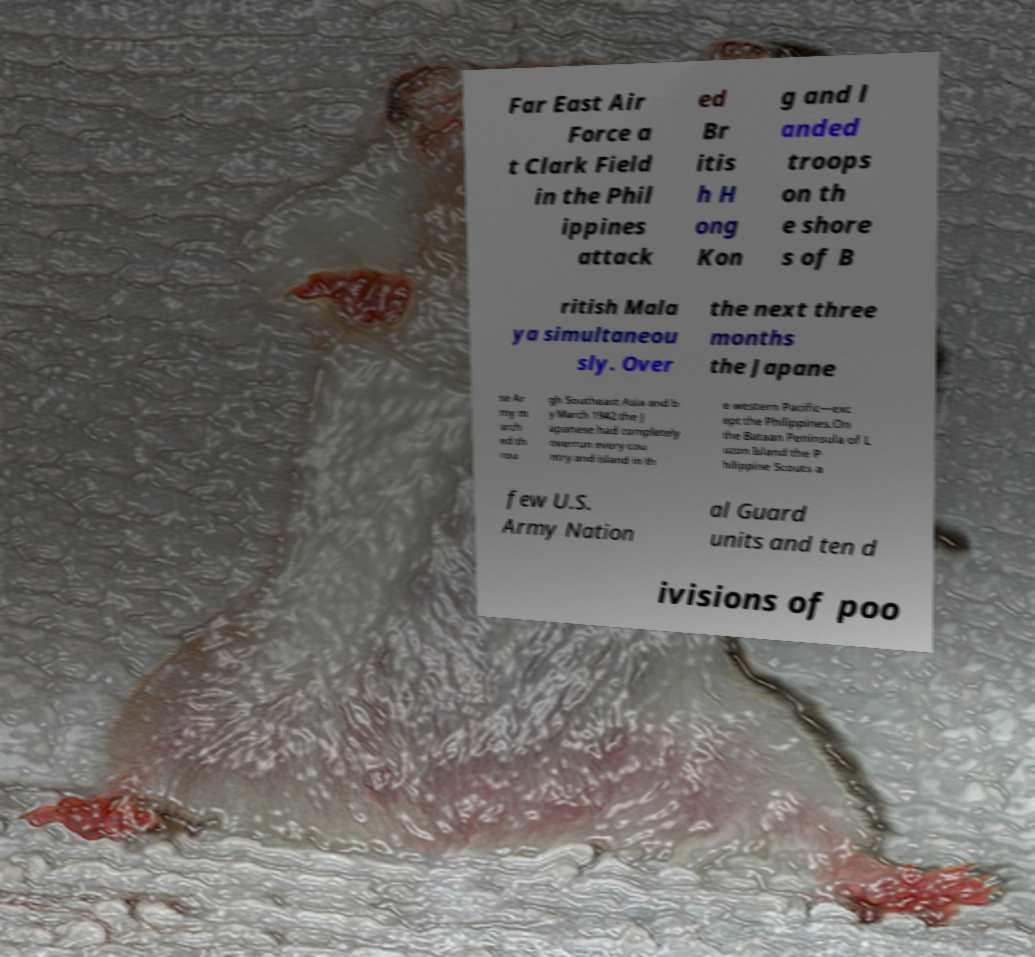Please identify and transcribe the text found in this image. Far East Air Force a t Clark Field in the Phil ippines attack ed Br itis h H ong Kon g and l anded troops on th e shore s of B ritish Mala ya simultaneou sly. Over the next three months the Japane se Ar my m arch ed th rou gh Southeast Asia and b y March 1942 the J apanese had completely overrun every cou ntry and island in th e western Pacific—exc ept the Philippines.On the Bataan Peninsula of L uzon Island the P hilippine Scouts a few U.S. Army Nation al Guard units and ten d ivisions of poo 